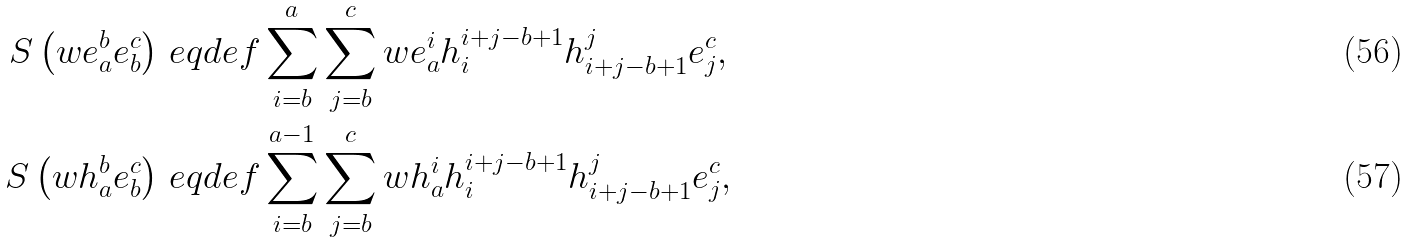Convert formula to latex. <formula><loc_0><loc_0><loc_500><loc_500>S \left ( w e _ { a } ^ { b } e _ { b } ^ { c } \right ) & \ e q d e f \sum _ { i = b } ^ { a } \sum _ { j = b } ^ { c } w e _ { a } ^ { i } h _ { i } ^ { i + j - b + 1 } h _ { i + j - b + 1 } ^ { j } e _ { j } ^ { c } , \\ S \left ( w h _ { a } ^ { b } e _ { b } ^ { c } \right ) & \ e q d e f \sum _ { i = b } ^ { a - 1 } \sum _ { j = b } ^ { c } w h _ { a } ^ { i } h _ { i } ^ { i + j - b + 1 } h _ { i + j - b + 1 } ^ { j } e _ { j } ^ { c } ,</formula> 